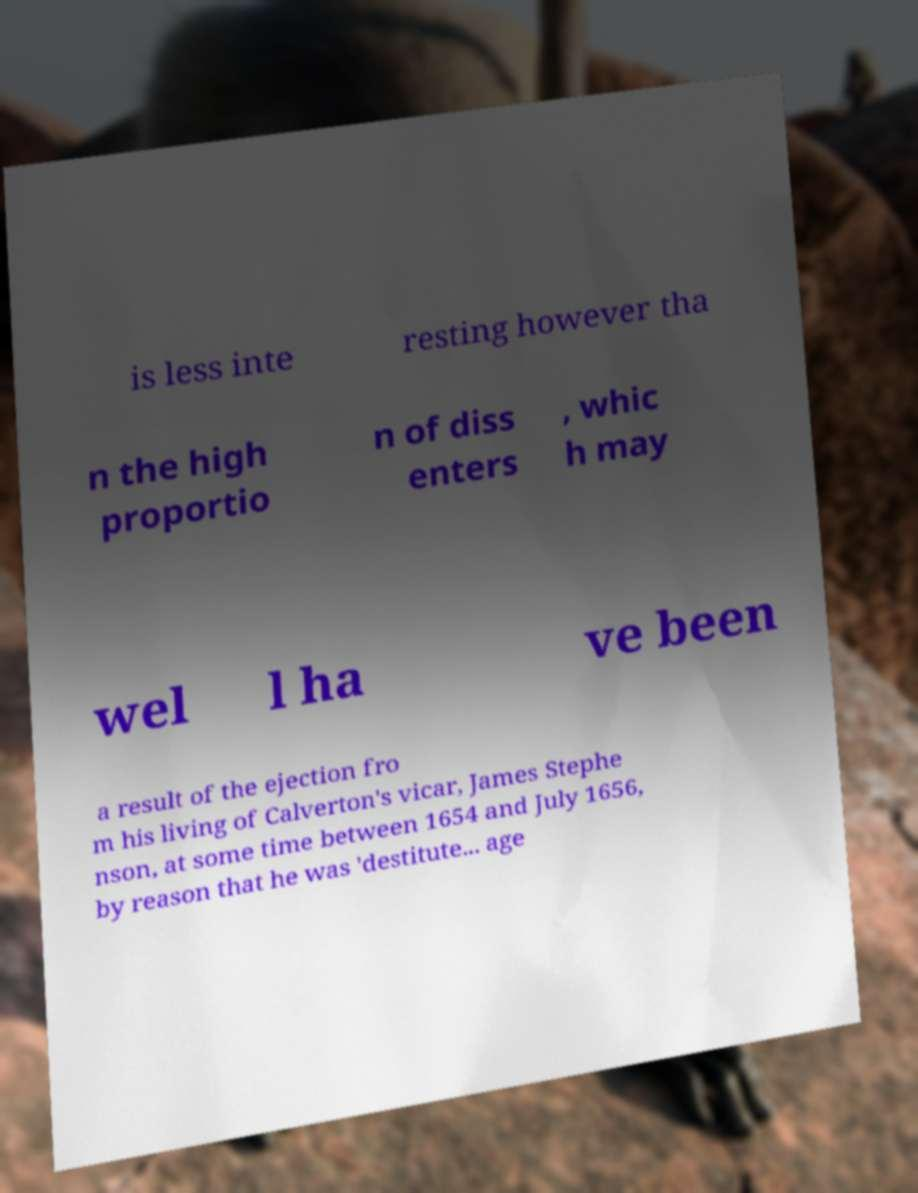Can you accurately transcribe the text from the provided image for me? is less inte resting however tha n the high proportio n of diss enters , whic h may wel l ha ve been a result of the ejection fro m his living of Calverton's vicar, James Stephe nson, at some time between 1654 and July 1656, by reason that he was 'destitute... age 